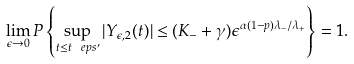Convert formula to latex. <formula><loc_0><loc_0><loc_500><loc_500>\lim _ { \epsilon \rightarrow 0 } P \left \{ \sup _ { t \leq t _ { \ } e p s ^ { \prime } } | Y _ { \epsilon , 2 } ( t ) | \leq ( K _ { - } + \gamma ) \epsilon ^ { \alpha ( 1 - p ) \lambda _ { - } / \lambda _ { + } } \right \} = 1 .</formula> 